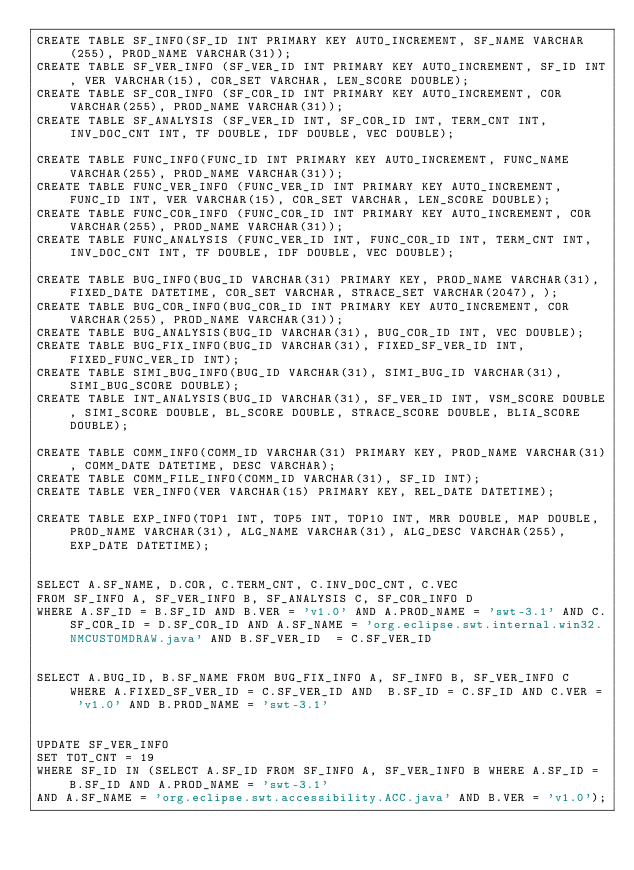<code> <loc_0><loc_0><loc_500><loc_500><_SQL_>CREATE TABLE SF_INFO(SF_ID INT PRIMARY KEY AUTO_INCREMENT, SF_NAME VARCHAR(255), PROD_NAME VARCHAR(31));
CREATE TABLE SF_VER_INFO (SF_VER_ID INT PRIMARY KEY AUTO_INCREMENT, SF_ID INT, VER VARCHAR(15), COR_SET VARCHAR, LEN_SCORE DOUBLE);
CREATE TABLE SF_COR_INFO (SF_COR_ID INT PRIMARY KEY AUTO_INCREMENT, COR VARCHAR(255), PROD_NAME VARCHAR(31));
CREATE TABLE SF_ANALYSIS (SF_VER_ID INT, SF_COR_ID INT, TERM_CNT INT, INV_DOC_CNT INT, TF DOUBLE, IDF DOUBLE, VEC DOUBLE);

CREATE TABLE FUNC_INFO(FUNC_ID INT PRIMARY KEY AUTO_INCREMENT, FUNC_NAME VARCHAR(255), PROD_NAME VARCHAR(31));
CREATE TABLE FUNC_VER_INFO (FUNC_VER_ID INT PRIMARY KEY AUTO_INCREMENT, FUNC_ID INT, VER VARCHAR(15), COR_SET VARCHAR, LEN_SCORE DOUBLE);
CREATE TABLE FUNC_COR_INFO (FUNC_COR_ID INT PRIMARY KEY AUTO_INCREMENT, COR VARCHAR(255), PROD_NAME VARCHAR(31));
CREATE TABLE FUNC_ANALYSIS (FUNC_VER_ID INT, FUNC_COR_ID INT, TERM_CNT INT, INV_DOC_CNT INT, TF DOUBLE, IDF DOUBLE, VEC DOUBLE);

CREATE TABLE BUG_INFO(BUG_ID VARCHAR(31) PRIMARY KEY, PROD_NAME VARCHAR(31), FIXED_DATE DATETIME, COR_SET VARCHAR, STRACE_SET VARCHAR(2047), );
CREATE TABLE BUG_COR_INFO(BUG_COR_ID INT PRIMARY KEY AUTO_INCREMENT, COR VARCHAR(255), PROD_NAME VARCHAR(31));
CREATE TABLE BUG_ANALYSIS(BUG_ID VARCHAR(31), BUG_COR_ID INT, VEC DOUBLE);
CREATE TABLE BUG_FIX_INFO(BUG_ID VARCHAR(31), FIXED_SF_VER_ID INT, FIXED_FUNC_VER_ID INT);
CREATE TABLE SIMI_BUG_INFO(BUG_ID VARCHAR(31), SIMI_BUG_ID VARCHAR(31), SIMI_BUG_SCORE DOUBLE);
CREATE TABLE INT_ANALYSIS(BUG_ID VARCHAR(31), SF_VER_ID INT, VSM_SCORE DOUBLE, SIMI_SCORE DOUBLE, BL_SCORE DOUBLE, STRACE_SCORE DOUBLE, BLIA_SCORE DOUBLE);

CREATE TABLE COMM_INFO(COMM_ID VARCHAR(31) PRIMARY KEY, PROD_NAME VARCHAR(31), COMM_DATE DATETIME, DESC VARCHAR);
CREATE TABLE COMM_FILE_INFO(COMM_ID VARCHAR(31), SF_ID INT);
CREATE TABLE VER_INFO(VER VARCHAR(15) PRIMARY KEY, REL_DATE DATETIME);

CREATE TABLE EXP_INFO(TOP1 INT, TOP5 INT, TOP10 INT, MRR DOUBLE, MAP DOUBLE, PROD_NAME VARCHAR(31), ALG_NAME VARCHAR(31), ALG_DESC VARCHAR(255), EXP_DATE DATETIME);


SELECT A.SF_NAME, D.COR, C.TERM_CNT, C.INV_DOC_CNT, C.VEC
FROM SF_INFO A, SF_VER_INFO B, SF_ANALYSIS C, SF_COR_INFO D
WHERE A.SF_ID = B.SF_ID AND B.VER = 'v1.0' AND A.PROD_NAME = 'swt-3.1' AND C.SF_COR_ID = D.SF_COR_ID AND A.SF_NAME = 'org.eclipse.swt.internal.win32.NMCUSTOMDRAW.java' AND B.SF_VER_ID  = C.SF_VER_ID


SELECT A.BUG_ID, B.SF_NAME FROM BUG_FIX_INFO A, SF_INFO B, SF_VER_INFO C WHERE A.FIXED_SF_VER_ID = C.SF_VER_ID AND  B.SF_ID = C.SF_ID AND C.VER = 'v1.0' AND B.PROD_NAME = 'swt-3.1'


UPDATE SF_VER_INFO
SET TOT_CNT = 19
WHERE SF_ID IN (SELECT A.SF_ID FROM SF_INFO A, SF_VER_INFO B WHERE A.SF_ID = B.SF_ID AND A.PROD_NAME = 'swt-3.1'
AND A.SF_NAME = 'org.eclipse.swt.accessibility.ACC.java' AND B.VER = 'v1.0');
</code> 